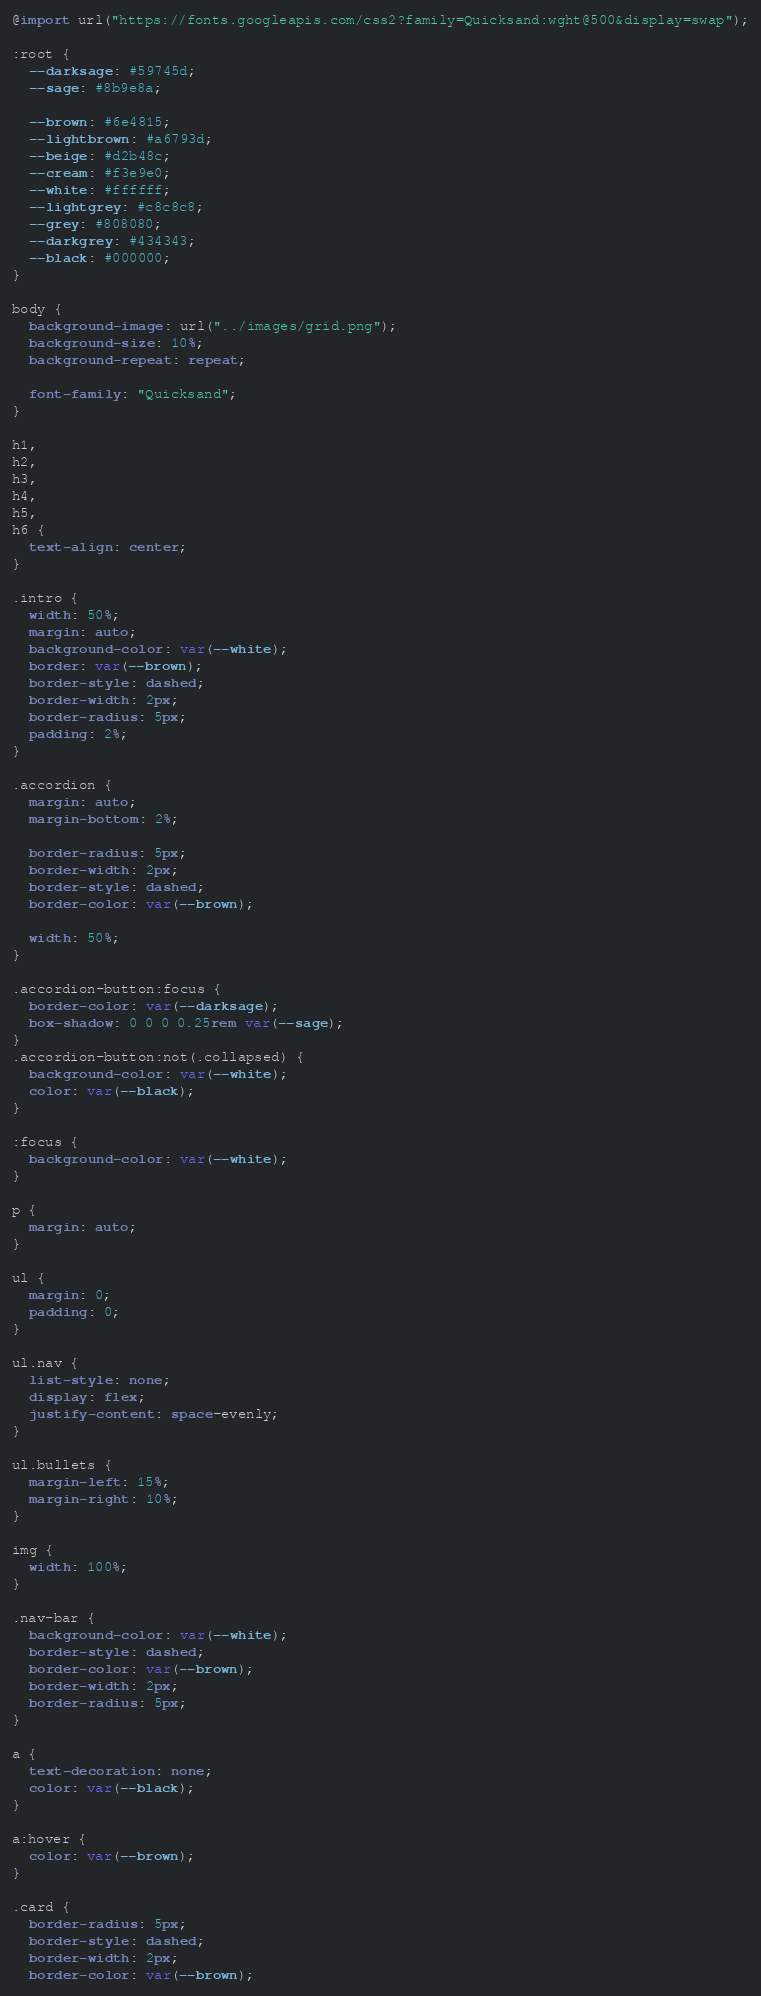Convert code to text. <code><loc_0><loc_0><loc_500><loc_500><_CSS_>@import url("https://fonts.googleapis.com/css2?family=Quicksand:wght@500&display=swap");

:root {
  --darksage: #59745d;
  --sage: #8b9e8a;

  --brown: #6e4815;
  --lightbrown: #a6793d;
  --beige: #d2b48c;
  --cream: #f3e9e0;
  --white: #ffffff;
  --lightgrey: #c8c8c8;
  --grey: #808080;
  --darkgrey: #434343;
  --black: #000000;
}

body {
  background-image: url("../images/grid.png");
  background-size: 10%;
  background-repeat: repeat;

  font-family: "Quicksand";
}

h1,
h2,
h3,
h4,
h5,
h6 {
  text-align: center;
}

.intro {
  width: 50%;
  margin: auto;
  background-color: var(--white);
  border: var(--brown);
  border-style: dashed;
  border-width: 2px;
  border-radius: 5px;
  padding: 2%;
}

.accordion {
  margin: auto;
  margin-bottom: 2%;

  border-radius: 5px;
  border-width: 2px;
  border-style: dashed;
  border-color: var(--brown);

  width: 50%;
}

.accordion-button:focus {
  border-color: var(--darksage);
  box-shadow: 0 0 0 0.25rem var(--sage);
}
.accordion-button:not(.collapsed) {
  background-color: var(--white);
  color: var(--black);
}

:focus {
  background-color: var(--white);
}

p {
  margin: auto;
}

ul {
  margin: 0;
  padding: 0;
}

ul.nav {
  list-style: none;
  display: flex;
  justify-content: space-evenly;
}

ul.bullets {
  margin-left: 15%;
  margin-right: 10%;
}

img {
  width: 100%;
}

.nav-bar {
  background-color: var(--white);
  border-style: dashed;
  border-color: var(--brown);
  border-width: 2px;
  border-radius: 5px;
}

a {
  text-decoration: none;
  color: var(--black);
}

a:hover {
  color: var(--brown);
}

.card {
  border-radius: 5px;
  border-style: dashed;
  border-width: 2px;
  border-color: var(--brown);
</code> 